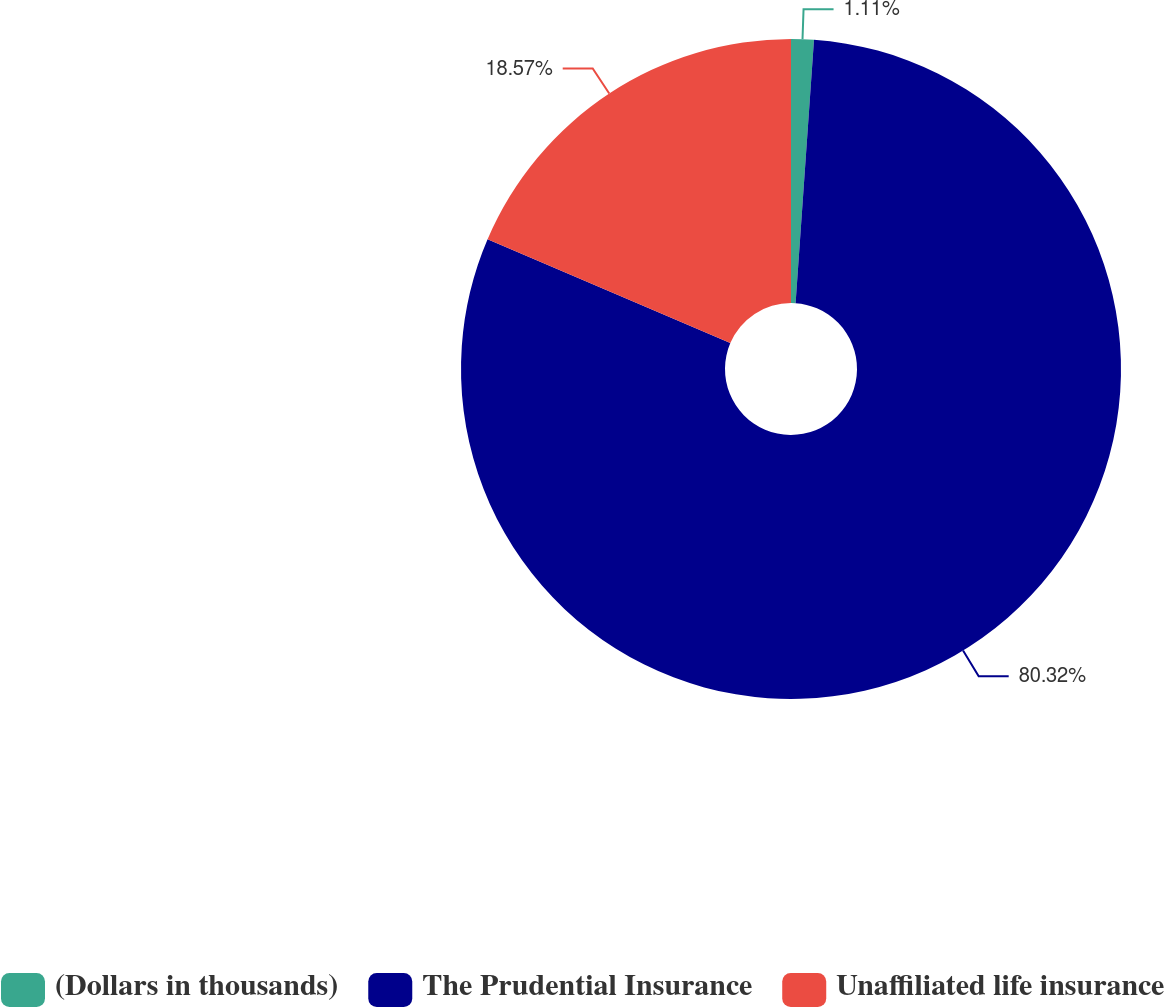Convert chart. <chart><loc_0><loc_0><loc_500><loc_500><pie_chart><fcel>(Dollars in thousands)<fcel>The Prudential Insurance<fcel>Unaffiliated life insurance<nl><fcel>1.11%<fcel>80.33%<fcel>18.57%<nl></chart> 